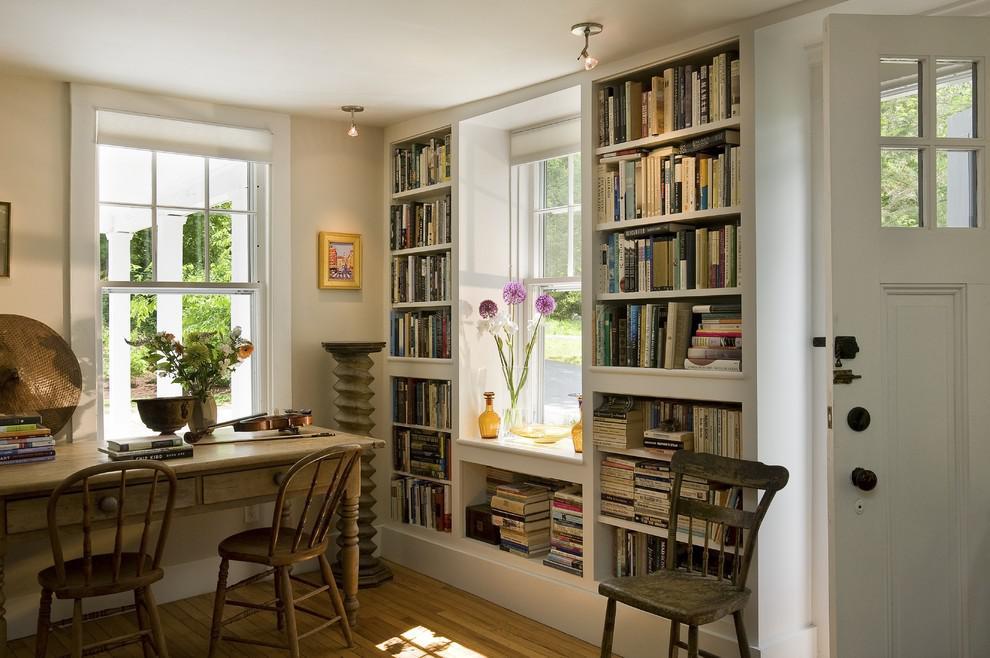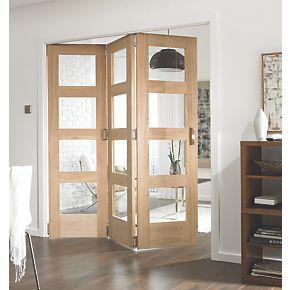The first image is the image on the left, the second image is the image on the right. For the images displayed, is the sentence "An image shows a white room with tall white bookcases and something that opens into the next room and a facing window." factually correct? Answer yes or no. No. 